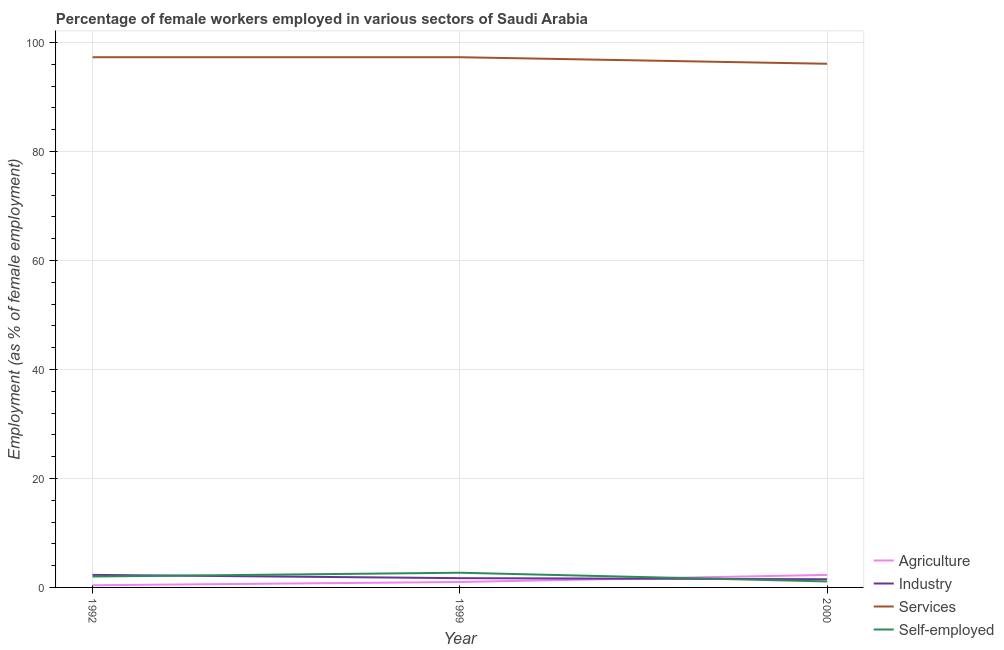How many different coloured lines are there?
Provide a succinct answer. 4. What is the percentage of self employed female workers in 1999?
Keep it short and to the point. 2.7. Across all years, what is the maximum percentage of self employed female workers?
Provide a succinct answer. 2.7. Across all years, what is the minimum percentage of female workers in agriculture?
Keep it short and to the point. 0.4. In which year was the percentage of female workers in agriculture maximum?
Your answer should be compact. 2000. What is the difference between the percentage of female workers in services in 1999 and that in 2000?
Your answer should be very brief. 1.2. What is the difference between the percentage of female workers in industry in 1992 and the percentage of female workers in services in 1999?
Your answer should be very brief. -95. What is the average percentage of female workers in services per year?
Your answer should be very brief. 96.9. In the year 2000, what is the difference between the percentage of self employed female workers and percentage of female workers in industry?
Provide a succinct answer. -0.4. What is the ratio of the percentage of female workers in services in 1999 to that in 2000?
Ensure brevity in your answer.  1.01. Is the percentage of female workers in industry in 1992 less than that in 1999?
Offer a terse response. No. What is the difference between the highest and the second highest percentage of female workers in industry?
Your answer should be compact. 0.6. What is the difference between the highest and the lowest percentage of self employed female workers?
Provide a succinct answer. 1.6. In how many years, is the percentage of female workers in services greater than the average percentage of female workers in services taken over all years?
Your answer should be very brief. 2. Is the sum of the percentage of female workers in services in 1992 and 2000 greater than the maximum percentage of self employed female workers across all years?
Your answer should be compact. Yes. Is it the case that in every year, the sum of the percentage of female workers in agriculture and percentage of female workers in industry is greater than the percentage of female workers in services?
Your answer should be very brief. No. How many years are there in the graph?
Ensure brevity in your answer.  3. What is the difference between two consecutive major ticks on the Y-axis?
Give a very brief answer. 20. Does the graph contain grids?
Your answer should be compact. Yes. How are the legend labels stacked?
Ensure brevity in your answer.  Vertical. What is the title of the graph?
Make the answer very short. Percentage of female workers employed in various sectors of Saudi Arabia. What is the label or title of the X-axis?
Your answer should be compact. Year. What is the label or title of the Y-axis?
Keep it short and to the point. Employment (as % of female employment). What is the Employment (as % of female employment) in Agriculture in 1992?
Your answer should be compact. 0.4. What is the Employment (as % of female employment) in Industry in 1992?
Offer a very short reply. 2.3. What is the Employment (as % of female employment) in Services in 1992?
Keep it short and to the point. 97.3. What is the Employment (as % of female employment) of Self-employed in 1992?
Your answer should be very brief. 2. What is the Employment (as % of female employment) of Agriculture in 1999?
Provide a succinct answer. 1. What is the Employment (as % of female employment) in Industry in 1999?
Give a very brief answer. 1.7. What is the Employment (as % of female employment) of Services in 1999?
Make the answer very short. 97.3. What is the Employment (as % of female employment) of Self-employed in 1999?
Your answer should be compact. 2.7. What is the Employment (as % of female employment) in Agriculture in 2000?
Give a very brief answer. 2.3. What is the Employment (as % of female employment) in Industry in 2000?
Provide a short and direct response. 1.5. What is the Employment (as % of female employment) in Services in 2000?
Make the answer very short. 96.1. What is the Employment (as % of female employment) in Self-employed in 2000?
Your answer should be compact. 1.1. Across all years, what is the maximum Employment (as % of female employment) of Agriculture?
Provide a short and direct response. 2.3. Across all years, what is the maximum Employment (as % of female employment) in Industry?
Offer a very short reply. 2.3. Across all years, what is the maximum Employment (as % of female employment) of Services?
Give a very brief answer. 97.3. Across all years, what is the maximum Employment (as % of female employment) of Self-employed?
Provide a short and direct response. 2.7. Across all years, what is the minimum Employment (as % of female employment) in Agriculture?
Keep it short and to the point. 0.4. Across all years, what is the minimum Employment (as % of female employment) in Industry?
Your answer should be compact. 1.5. Across all years, what is the minimum Employment (as % of female employment) in Services?
Ensure brevity in your answer.  96.1. Across all years, what is the minimum Employment (as % of female employment) in Self-employed?
Your response must be concise. 1.1. What is the total Employment (as % of female employment) of Industry in the graph?
Your answer should be compact. 5.5. What is the total Employment (as % of female employment) in Services in the graph?
Your answer should be compact. 290.7. What is the total Employment (as % of female employment) in Self-employed in the graph?
Your answer should be compact. 5.8. What is the difference between the Employment (as % of female employment) of Industry in 1992 and that in 1999?
Provide a succinct answer. 0.6. What is the difference between the Employment (as % of female employment) in Services in 1992 and that in 1999?
Give a very brief answer. 0. What is the difference between the Employment (as % of female employment) of Services in 1992 and that in 2000?
Give a very brief answer. 1.2. What is the difference between the Employment (as % of female employment) of Self-employed in 1992 and that in 2000?
Ensure brevity in your answer.  0.9. What is the difference between the Employment (as % of female employment) of Agriculture in 1999 and that in 2000?
Offer a terse response. -1.3. What is the difference between the Employment (as % of female employment) of Services in 1999 and that in 2000?
Give a very brief answer. 1.2. What is the difference between the Employment (as % of female employment) in Self-employed in 1999 and that in 2000?
Keep it short and to the point. 1.6. What is the difference between the Employment (as % of female employment) of Agriculture in 1992 and the Employment (as % of female employment) of Industry in 1999?
Ensure brevity in your answer.  -1.3. What is the difference between the Employment (as % of female employment) of Agriculture in 1992 and the Employment (as % of female employment) of Services in 1999?
Your answer should be compact. -96.9. What is the difference between the Employment (as % of female employment) of Agriculture in 1992 and the Employment (as % of female employment) of Self-employed in 1999?
Offer a very short reply. -2.3. What is the difference between the Employment (as % of female employment) of Industry in 1992 and the Employment (as % of female employment) of Services in 1999?
Give a very brief answer. -95. What is the difference between the Employment (as % of female employment) of Services in 1992 and the Employment (as % of female employment) of Self-employed in 1999?
Ensure brevity in your answer.  94.6. What is the difference between the Employment (as % of female employment) of Agriculture in 1992 and the Employment (as % of female employment) of Industry in 2000?
Your answer should be very brief. -1.1. What is the difference between the Employment (as % of female employment) of Agriculture in 1992 and the Employment (as % of female employment) of Services in 2000?
Your answer should be very brief. -95.7. What is the difference between the Employment (as % of female employment) in Agriculture in 1992 and the Employment (as % of female employment) in Self-employed in 2000?
Ensure brevity in your answer.  -0.7. What is the difference between the Employment (as % of female employment) in Industry in 1992 and the Employment (as % of female employment) in Services in 2000?
Make the answer very short. -93.8. What is the difference between the Employment (as % of female employment) in Services in 1992 and the Employment (as % of female employment) in Self-employed in 2000?
Provide a succinct answer. 96.2. What is the difference between the Employment (as % of female employment) in Agriculture in 1999 and the Employment (as % of female employment) in Industry in 2000?
Provide a short and direct response. -0.5. What is the difference between the Employment (as % of female employment) of Agriculture in 1999 and the Employment (as % of female employment) of Services in 2000?
Your answer should be compact. -95.1. What is the difference between the Employment (as % of female employment) in Industry in 1999 and the Employment (as % of female employment) in Services in 2000?
Offer a terse response. -94.4. What is the difference between the Employment (as % of female employment) of Services in 1999 and the Employment (as % of female employment) of Self-employed in 2000?
Offer a terse response. 96.2. What is the average Employment (as % of female employment) of Agriculture per year?
Ensure brevity in your answer.  1.23. What is the average Employment (as % of female employment) in Industry per year?
Make the answer very short. 1.83. What is the average Employment (as % of female employment) in Services per year?
Give a very brief answer. 96.9. What is the average Employment (as % of female employment) in Self-employed per year?
Offer a terse response. 1.93. In the year 1992, what is the difference between the Employment (as % of female employment) of Agriculture and Employment (as % of female employment) of Services?
Offer a very short reply. -96.9. In the year 1992, what is the difference between the Employment (as % of female employment) of Industry and Employment (as % of female employment) of Services?
Give a very brief answer. -95. In the year 1992, what is the difference between the Employment (as % of female employment) of Services and Employment (as % of female employment) of Self-employed?
Make the answer very short. 95.3. In the year 1999, what is the difference between the Employment (as % of female employment) in Agriculture and Employment (as % of female employment) in Industry?
Keep it short and to the point. -0.7. In the year 1999, what is the difference between the Employment (as % of female employment) in Agriculture and Employment (as % of female employment) in Services?
Ensure brevity in your answer.  -96.3. In the year 1999, what is the difference between the Employment (as % of female employment) of Industry and Employment (as % of female employment) of Services?
Ensure brevity in your answer.  -95.6. In the year 1999, what is the difference between the Employment (as % of female employment) of Services and Employment (as % of female employment) of Self-employed?
Keep it short and to the point. 94.6. In the year 2000, what is the difference between the Employment (as % of female employment) in Agriculture and Employment (as % of female employment) in Services?
Give a very brief answer. -93.8. In the year 2000, what is the difference between the Employment (as % of female employment) in Agriculture and Employment (as % of female employment) in Self-employed?
Your response must be concise. 1.2. In the year 2000, what is the difference between the Employment (as % of female employment) of Industry and Employment (as % of female employment) of Services?
Give a very brief answer. -94.6. In the year 2000, what is the difference between the Employment (as % of female employment) in Industry and Employment (as % of female employment) in Self-employed?
Provide a short and direct response. 0.4. What is the ratio of the Employment (as % of female employment) of Industry in 1992 to that in 1999?
Your answer should be compact. 1.35. What is the ratio of the Employment (as % of female employment) of Services in 1992 to that in 1999?
Your answer should be compact. 1. What is the ratio of the Employment (as % of female employment) of Self-employed in 1992 to that in 1999?
Make the answer very short. 0.74. What is the ratio of the Employment (as % of female employment) of Agriculture in 1992 to that in 2000?
Provide a short and direct response. 0.17. What is the ratio of the Employment (as % of female employment) in Industry in 1992 to that in 2000?
Make the answer very short. 1.53. What is the ratio of the Employment (as % of female employment) in Services in 1992 to that in 2000?
Your response must be concise. 1.01. What is the ratio of the Employment (as % of female employment) in Self-employed in 1992 to that in 2000?
Your response must be concise. 1.82. What is the ratio of the Employment (as % of female employment) in Agriculture in 1999 to that in 2000?
Your answer should be very brief. 0.43. What is the ratio of the Employment (as % of female employment) of Industry in 1999 to that in 2000?
Keep it short and to the point. 1.13. What is the ratio of the Employment (as % of female employment) of Services in 1999 to that in 2000?
Give a very brief answer. 1.01. What is the ratio of the Employment (as % of female employment) in Self-employed in 1999 to that in 2000?
Offer a very short reply. 2.45. What is the difference between the highest and the second highest Employment (as % of female employment) in Industry?
Provide a succinct answer. 0.6. What is the difference between the highest and the lowest Employment (as % of female employment) in Industry?
Keep it short and to the point. 0.8. What is the difference between the highest and the lowest Employment (as % of female employment) of Services?
Make the answer very short. 1.2. What is the difference between the highest and the lowest Employment (as % of female employment) of Self-employed?
Provide a succinct answer. 1.6. 